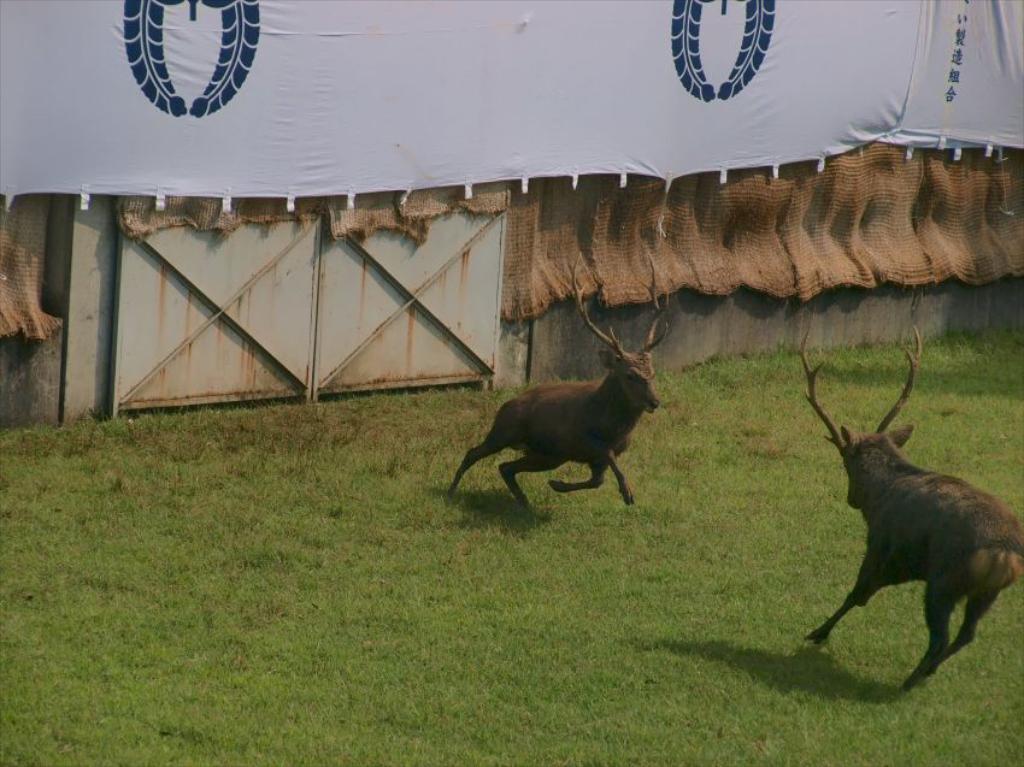Please provide a concise description of this image. In this image, we can see animals on the ground and in the background, there is a banner and we can see jute clothes and some boards are on the wall. 